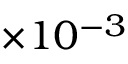Convert formula to latex. <formula><loc_0><loc_0><loc_500><loc_500>\times 1 0 ^ { - 3 }</formula> 